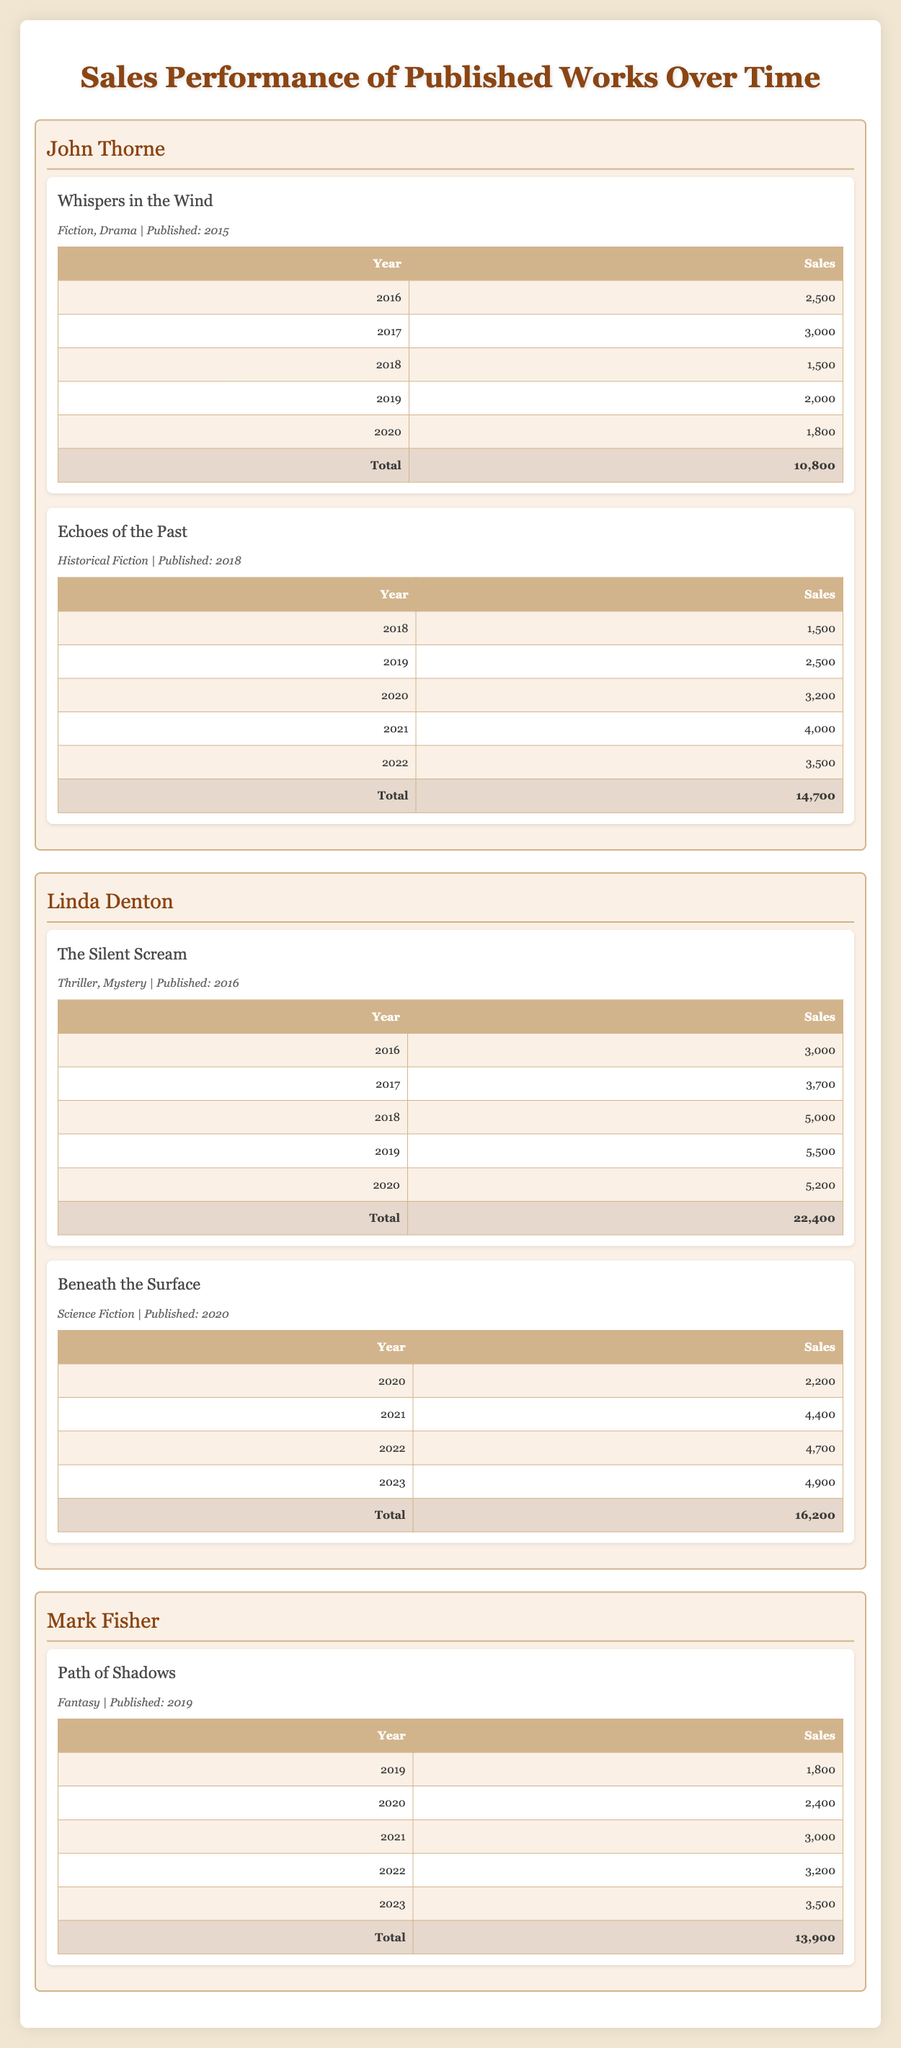What are the sales for "Whispers in the Wind" in 2017? In the table under the author John Thorne, I can find the sales information for "Whispers in the Wind." In 2017, it shows a sales figure of 3,000.
Answer: 3,000 What is the total sales for books authored by Linda Denton? Linda Denton has two books listed: "The Silent Scream" and "Beneath the Surface." The total sales for "The Silent Scream" is 22,400, and for "Beneath the Surface," it's 16,200. Adding these totals gives 22,400 + 16,200 = 38,600.
Answer: 38,600 Did John Thorne publish more than one book? John Thorne has two books listed in the table: "Whispers in the Wind" and "Echoes of the Past." Therefore, the statement is true.
Answer: Yes What was the highest sales year for "The Silent Scream"? In the table for "The Silent Scream," the sales figures were 3,000 in 2016, 3,700 in 2017, 5,000 in 2018, 5,500 in 2019, and 5,200 in 2020. The highest sales figure is 5,500 in 2019.
Answer: 5,500 Which author had the lowest total sales across their published works? The total sales for John Thorne is 10,800, Linda Denton is 38,600, and Mark Fisher is 13,900. The lowest total sales among these is John Thorne's at 10,800.
Answer: John Thorne What was the increase in sales from the first year to the last year for “Echoes of the Past”? The sales for "Echoes of the Past" started at 1,500 in 2018 and reached 3,500 in 2022. The difference in sales between these years is 3,500 - 1,500 = 2,000, indicating a positive increase.
Answer: 2,000 How do the total sales of Mark Fisher compare to Linda Denton? The total sales for Mark Fisher is 13,900, while for Linda Denton it is 38,600. To compare, 13,900 is less than 38,600, confirming that Mark Fisher had lower total sales than Linda Denton.
Answer: Less What is the average sales figure for all the books published in 2020? The authors published one book each with sales figures of 1,800 (John Thorne), 2,200 (Linda Denton), and 2,400 for Mark Fisher. Adding these gives 1,800 + 2,200 + 2,400 = 6,400. Dividing this by 3 gives an average of 6,400 / 3 = 2,133.33.
Answer: 2,133.33 